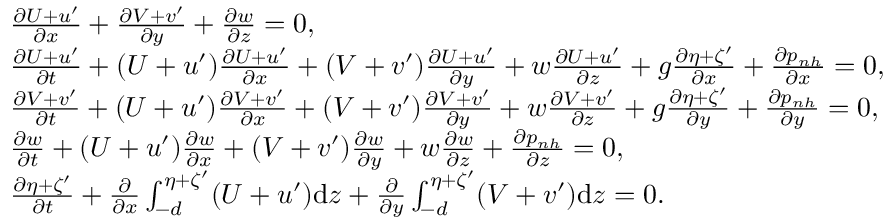<formula> <loc_0><loc_0><loc_500><loc_500>\begin{array} { r l } & { \frac { \partial U + u ^ { \prime } } { \partial x } + \frac { \partial V + v ^ { \prime } } { \partial y } + \frac { \partial w } { \partial z } = 0 , } \\ & { \frac { \partial U + u ^ { \prime } } { \partial t } + ( U + u ^ { \prime } ) \frac { \partial U + u ^ { \prime } } { \partial x } + ( V + v ^ { \prime } ) \frac { \partial U + u ^ { \prime } } { \partial y } + w \frac { \partial U + u ^ { \prime } } { \partial z } + g \frac { \partial \eta + \zeta ^ { \prime } } { \partial x } + \frac { \partial p _ { n h } } { \partial x } = 0 , } \\ & { \frac { \partial V + v ^ { \prime } } { \partial t } + ( U + u ^ { \prime } ) \frac { \partial V + v ^ { \prime } } { \partial x } + ( V + v ^ { \prime } ) \frac { \partial V + v ^ { \prime } } { \partial y } + w \frac { \partial V + v ^ { \prime } } { \partial z } + g \frac { \partial \eta + \zeta ^ { \prime } } { \partial y } + \frac { \partial p _ { n h } } { \partial y } = 0 , } \\ & { \frac { \partial w } { \partial t } + ( U + u ^ { \prime } ) \frac { \partial w } { \partial x } + ( V + v ^ { \prime } ) \frac { \partial w } { \partial y } + w \frac { \partial w } { \partial z } + \frac { \partial p _ { n h } } { \partial z } = 0 , } \\ & { \frac { \partial \eta + \zeta ^ { \prime } } { \partial t } + \frac { \partial } { \partial x } \int _ { - d } ^ { \eta + \zeta ^ { \prime } } ( U + u ^ { \prime } ) d z + \frac { \partial } { \partial y } \int _ { - d } ^ { \eta + \zeta ^ { \prime } } ( V + v ^ { \prime } ) d z = 0 . } \end{array}</formula> 